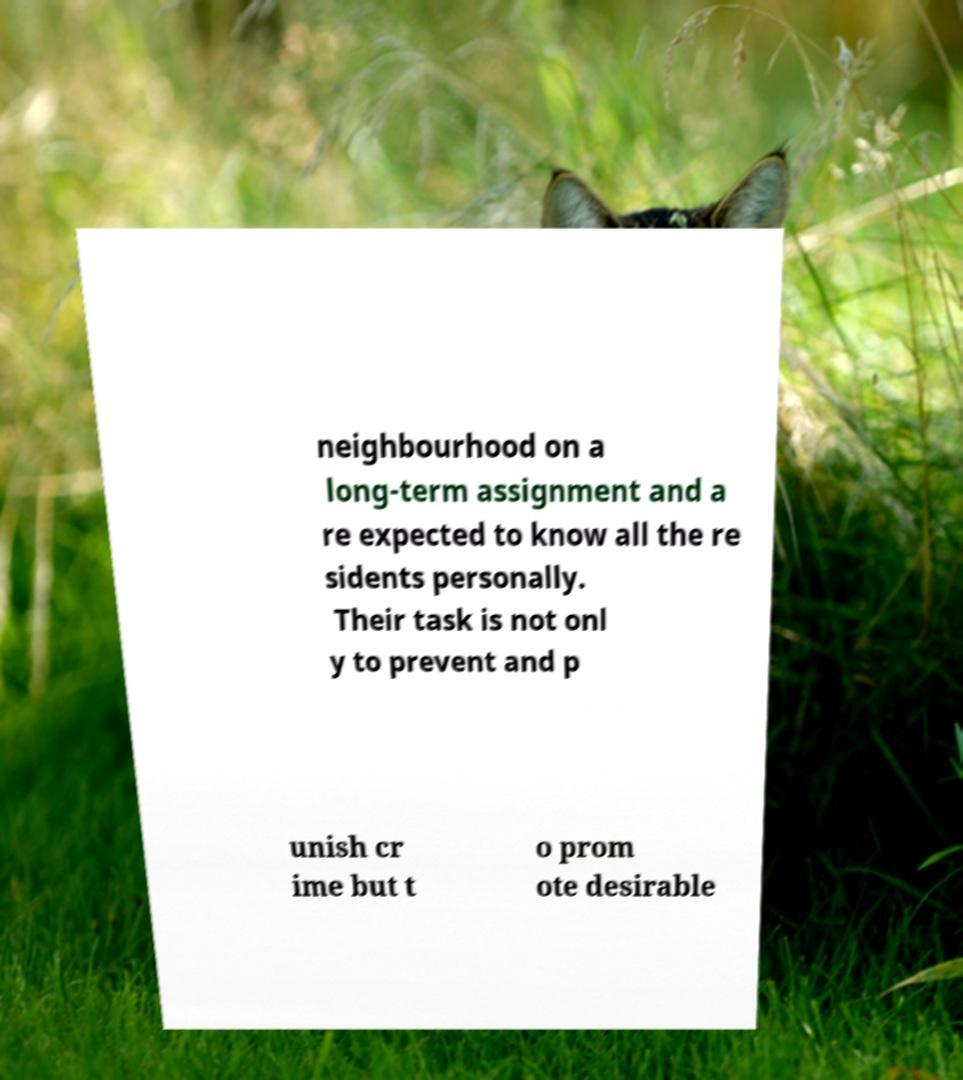Please read and relay the text visible in this image. What does it say? neighbourhood on a long-term assignment and a re expected to know all the re sidents personally. Their task is not onl y to prevent and p unish cr ime but t o prom ote desirable 